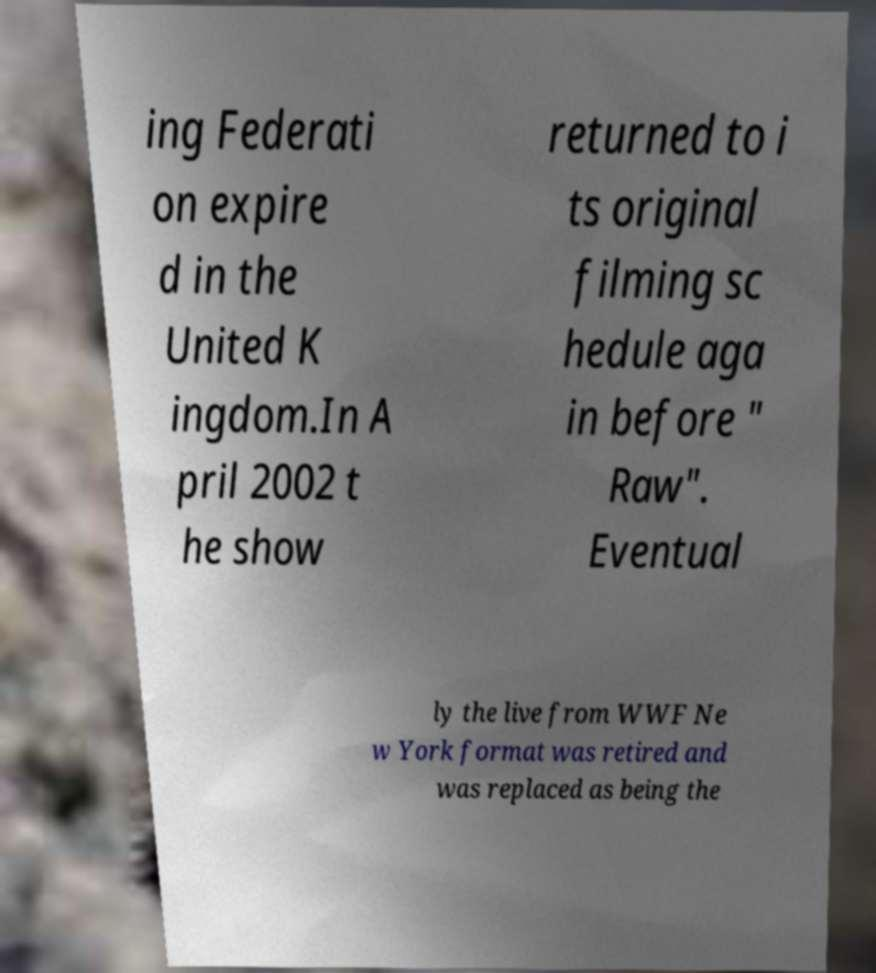Could you extract and type out the text from this image? ing Federati on expire d in the United K ingdom.In A pril 2002 t he show returned to i ts original filming sc hedule aga in before " Raw". Eventual ly the live from WWF Ne w York format was retired and was replaced as being the 